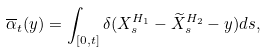Convert formula to latex. <formula><loc_0><loc_0><loc_500><loc_500>\overline { \alpha } _ { t } ( y ) & = \int _ { [ 0 , t ] } \delta ( X ^ { H _ { 1 } } _ { s } - \widetilde { X } ^ { H _ { 2 } } _ { s } - y ) d s ,</formula> 